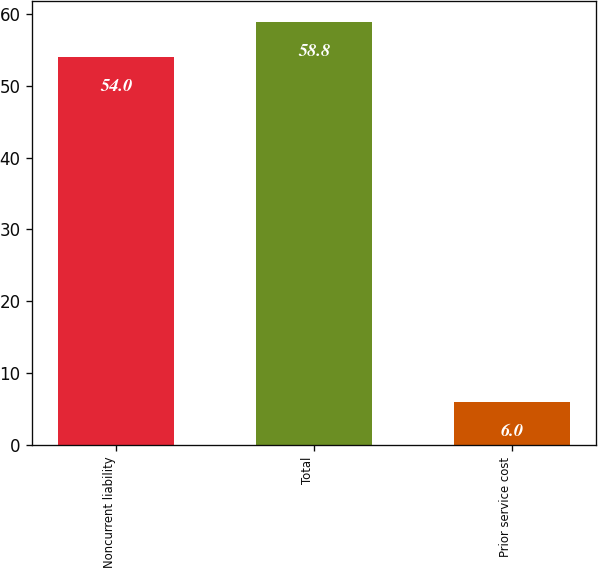Convert chart. <chart><loc_0><loc_0><loc_500><loc_500><bar_chart><fcel>Noncurrent liability<fcel>Total<fcel>Prior service cost<nl><fcel>54<fcel>58.8<fcel>6<nl></chart> 